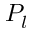Convert formula to latex. <formula><loc_0><loc_0><loc_500><loc_500>P _ { l }</formula> 